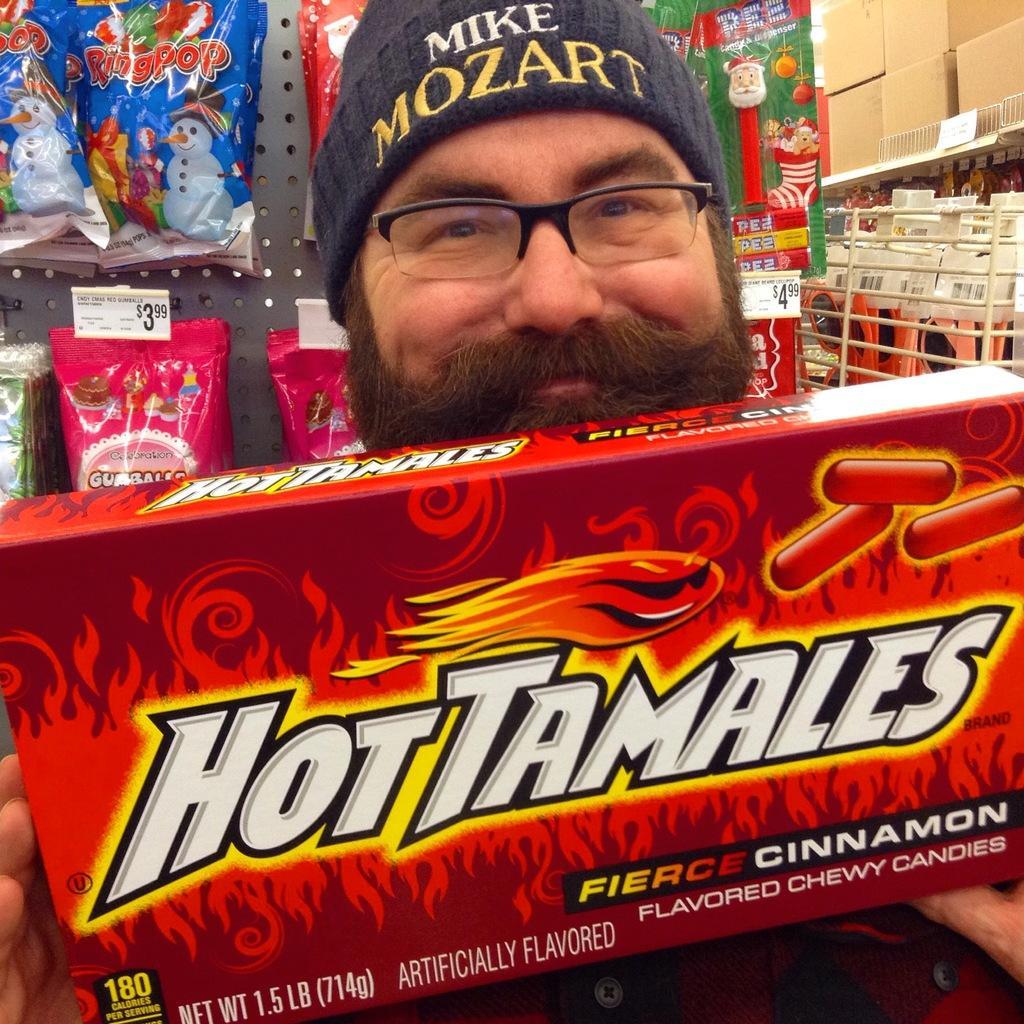How would you summarize this image in a sentence or two? In this picture I can see a man in front and I see that he is holding a box and I see something is written on the box. I can also see that he is wearing a cap. In the background I can see number of covers and boxes. 